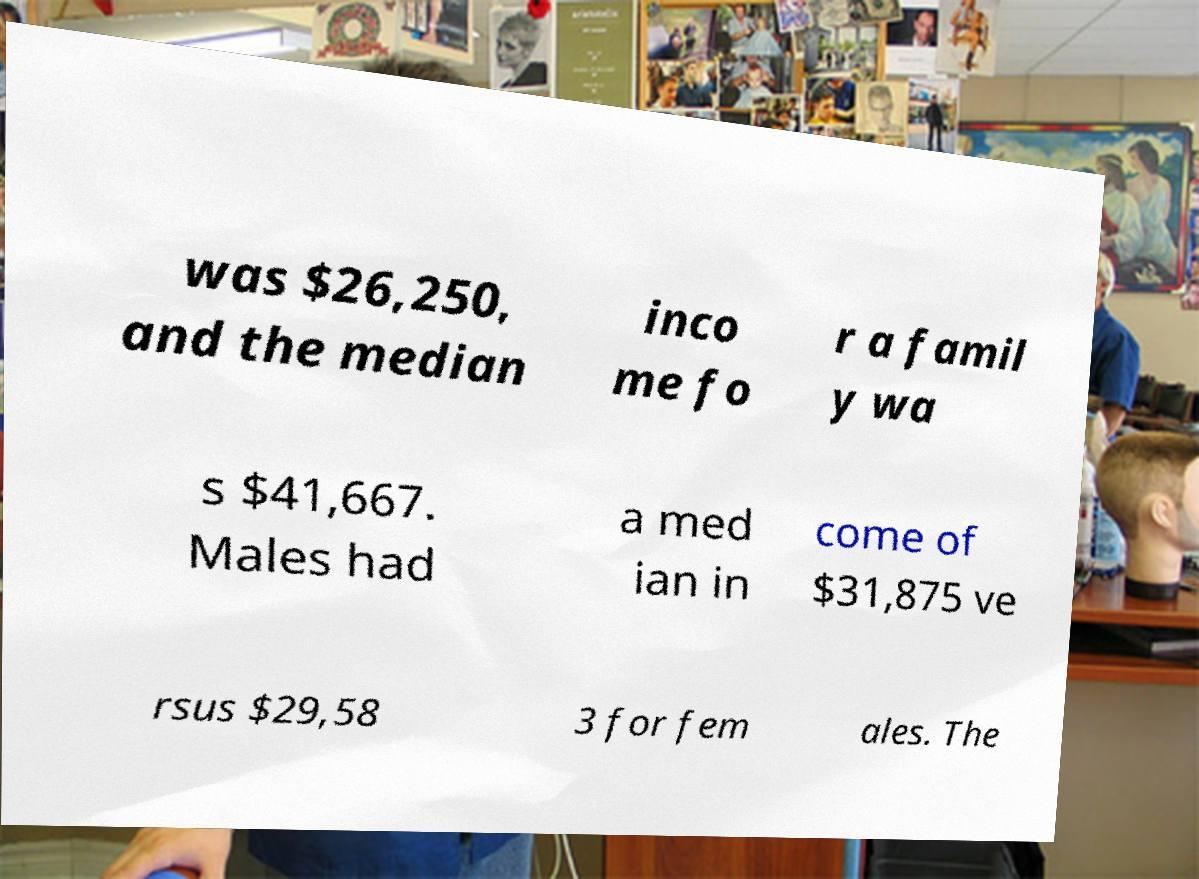Could you extract and type out the text from this image? was $26,250, and the median inco me fo r a famil y wa s $41,667. Males had a med ian in come of $31,875 ve rsus $29,58 3 for fem ales. The 